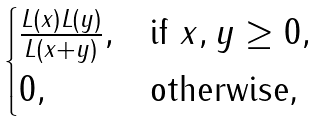<formula> <loc_0><loc_0><loc_500><loc_500>\begin{cases} \frac { L ( x ) L ( y ) } { L ( x + y ) } , & \text {if $x,y\geq 0,$} \\ 0 , & \text {otherwise,} \end{cases}</formula> 